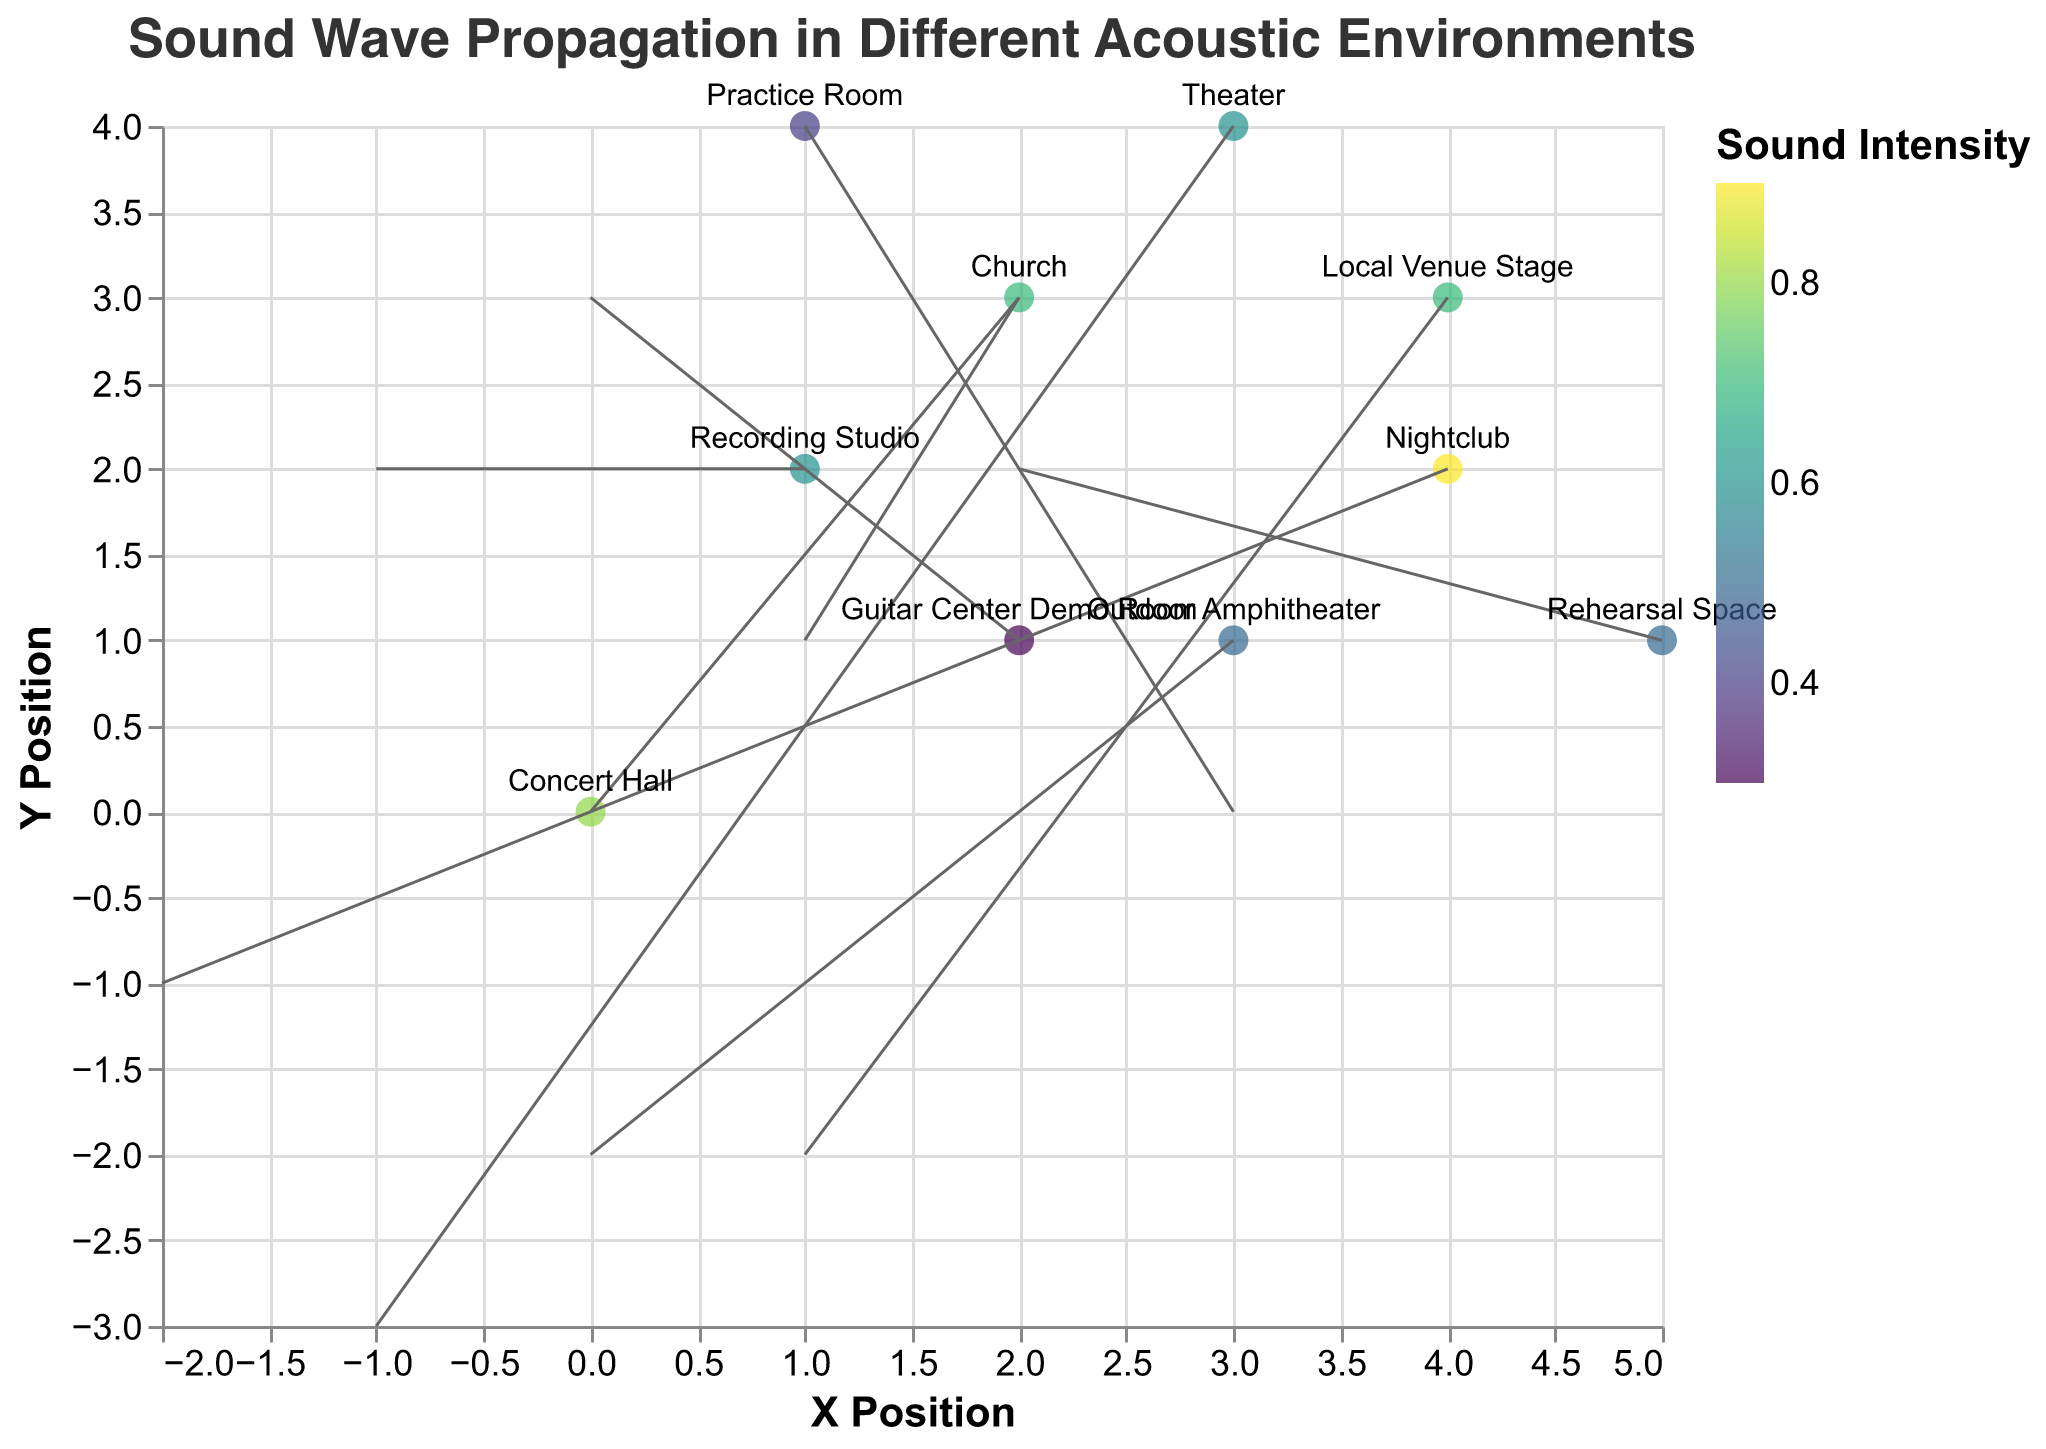What's the environment at position (1, 2)? The environment at position (1, 2) can be identified by looking at the data point labeled with text at that position.
Answer: Recording Studio In which environment is the sound intensity the highest? The environment with the highest sound intensity can be determined by looking at the color scale. The darkest point correlates with the highest intensity, which is 0.9.
Answer: Nightclub What is the direction of the sound wave at position (3, 1)? The direction of the sound wave at position (3, 1) is given by the vector (u, v) at this position. From the data, the vector is (0, -2), indicating downward.
Answer: Downward How many environments have sound intensity greater than 0.6? To determine this, we count how many points have intensity above 0.6: Concert Hall (0.8), Nightclub (0.9), Church (0.7), Local Venue Stage (0.7). There are 4 environments.
Answer: 4 Compare the sound propagation direction at positions (1, 4) and (3, 4)? The direction at (1, 4) is given by the vector (3, 0), indicating rightward. At (3, 4), the vector (-1, -3) indicates a downward-leftward direction. So, they are different.
Answer: Different Which point has the lowest sound intensity and what environment is it in? The point with the lowest sound intensity is 0.3 which corresponds to Guitar Center Demo Room.
Answer: Guitar Center Demo Room What are the coordinates of the vectors pointing downward? The vectors pointing downward have a negative v component. From the data, this occurs at (3, 1) [Outdoor Amphitheater], (4, 3) [Local Venue Stage], and (3, 4) [Theater].
Answer: (3, 1), (4, 3), (3, 4) Is there any environment where the sound vector points exactly horizontally? A sound vector points exactly horizontally if its v component is zero. The (1, 4) [Practice Room] vector (3, 0) fits this category.
Answer: Yes, Practice Room What's the average intensity of the environments where the vectors have positive x-components? The x-components are positive for (0, 0) [Concert Hall; 0.8], (2, 3) [Church; 0.7], (1, 4) [Practice Room; 0.4], (5, 1) [Rehearsal Space; 0.5], (4, 3) [Local Venue Stage; 0.7]. Summing these intensities (0.8 + 0.7 + 0.4 + 0.5 + 0.7) = 3.1, the average is 3.1 / 5 = 0.62.
Answer: 0.62 